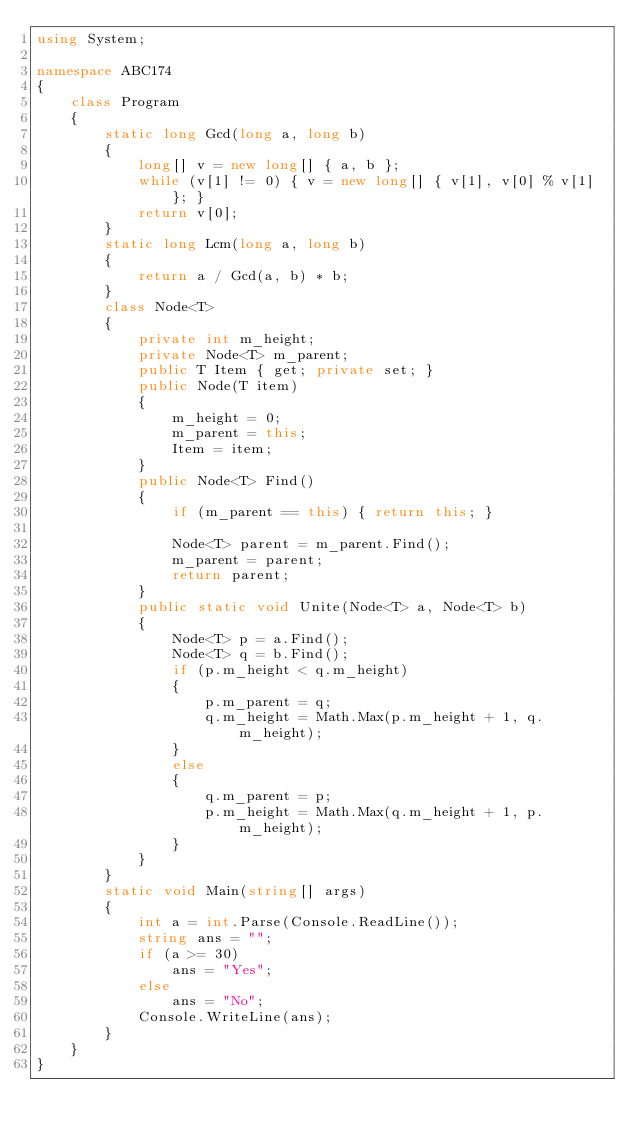<code> <loc_0><loc_0><loc_500><loc_500><_C#_>using System;

namespace ABC174
{
    class Program
    {
        static long Gcd(long a, long b)
        {
            long[] v = new long[] { a, b };
            while (v[1] != 0) { v = new long[] { v[1], v[0] % v[1] }; }
            return v[0];
        }
        static long Lcm(long a, long b)
        {
            return a / Gcd(a, b) * b;
        }
        class Node<T>
        {
            private int m_height;
            private Node<T> m_parent;
            public T Item { get; private set; }
            public Node(T item)
            {
                m_height = 0;
                m_parent = this;
                Item = item;
            }
            public Node<T> Find()
            {
                if (m_parent == this) { return this; }

                Node<T> parent = m_parent.Find();
                m_parent = parent;
                return parent;
            }
            public static void Unite(Node<T> a, Node<T> b)
            {
                Node<T> p = a.Find();
                Node<T> q = b.Find();
                if (p.m_height < q.m_height)
                {
                    p.m_parent = q;
                    q.m_height = Math.Max(p.m_height + 1, q.m_height);
                }
                else
                {
                    q.m_parent = p;
                    p.m_height = Math.Max(q.m_height + 1, p.m_height);
                }
            }
        }
        static void Main(string[] args)
        {
            int a = int.Parse(Console.ReadLine());
            string ans = "";
            if (a >= 30)
                ans = "Yes";
            else
                ans = "No";
            Console.WriteLine(ans);
        }
    }
}
</code> 